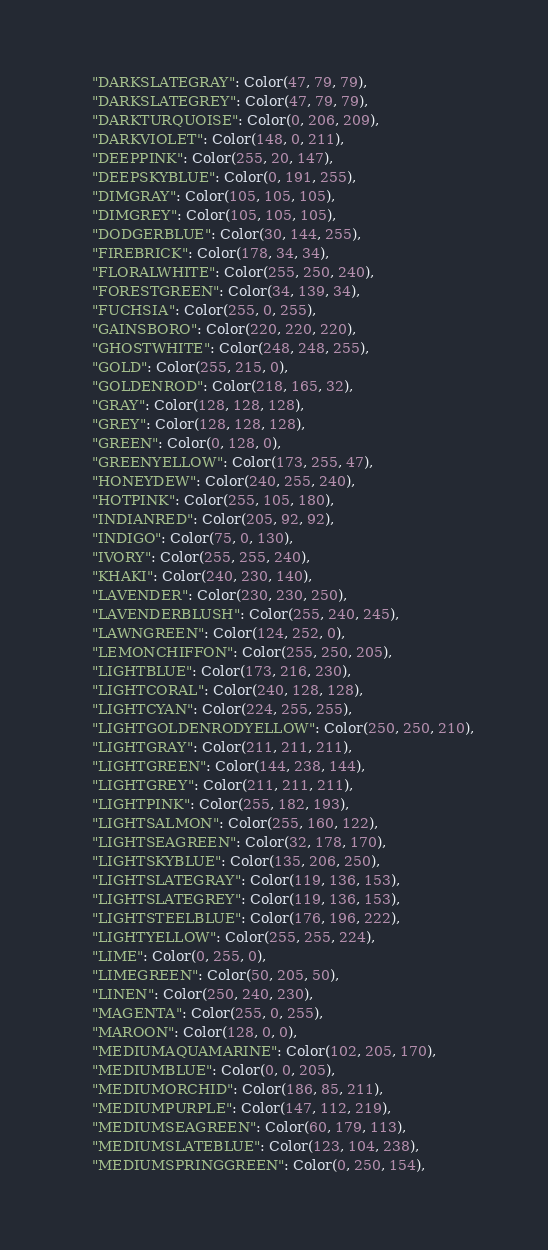<code> <loc_0><loc_0><loc_500><loc_500><_Python_>    "DARKSLATEGRAY": Color(47, 79, 79),
    "DARKSLATEGREY": Color(47, 79, 79),
    "DARKTURQUOISE": Color(0, 206, 209),
    "DARKVIOLET": Color(148, 0, 211),
    "DEEPPINK": Color(255, 20, 147),
    "DEEPSKYBLUE": Color(0, 191, 255),
    "DIMGRAY": Color(105, 105, 105),
    "DIMGREY": Color(105, 105, 105),
    "DODGERBLUE": Color(30, 144, 255),
    "FIREBRICK": Color(178, 34, 34),
    "FLORALWHITE": Color(255, 250, 240),
    "FORESTGREEN": Color(34, 139, 34),
    "FUCHSIA": Color(255, 0, 255),
    "GAINSBORO": Color(220, 220, 220),
    "GHOSTWHITE": Color(248, 248, 255),
    "GOLD": Color(255, 215, 0),
    "GOLDENROD": Color(218, 165, 32),
    "GRAY": Color(128, 128, 128),
    "GREY": Color(128, 128, 128),
    "GREEN": Color(0, 128, 0),
    "GREENYELLOW": Color(173, 255, 47),
    "HONEYDEW": Color(240, 255, 240),
    "HOTPINK": Color(255, 105, 180),
    "INDIANRED": Color(205, 92, 92),
    "INDIGO": Color(75, 0, 130),
    "IVORY": Color(255, 255, 240),
    "KHAKI": Color(240, 230, 140),
    "LAVENDER": Color(230, 230, 250),
    "LAVENDERBLUSH": Color(255, 240, 245),
    "LAWNGREEN": Color(124, 252, 0),
    "LEMONCHIFFON": Color(255, 250, 205),
    "LIGHTBLUE": Color(173, 216, 230),
    "LIGHTCORAL": Color(240, 128, 128),
    "LIGHTCYAN": Color(224, 255, 255),
    "LIGHTGOLDENRODYELLOW": Color(250, 250, 210),
    "LIGHTGRAY": Color(211, 211, 211),
    "LIGHTGREEN": Color(144, 238, 144),
    "LIGHTGREY": Color(211, 211, 211),
    "LIGHTPINK": Color(255, 182, 193),
    "LIGHTSALMON": Color(255, 160, 122),
    "LIGHTSEAGREEN": Color(32, 178, 170),
    "LIGHTSKYBLUE": Color(135, 206, 250),
    "LIGHTSLATEGRAY": Color(119, 136, 153),
    "LIGHTSLATEGREY": Color(119, 136, 153),
    "LIGHTSTEELBLUE": Color(176, 196, 222),
    "LIGHTYELLOW": Color(255, 255, 224),
    "LIME": Color(0, 255, 0),
    "LIMEGREEN": Color(50, 205, 50),
    "LINEN": Color(250, 240, 230),
    "MAGENTA": Color(255, 0, 255),
    "MAROON": Color(128, 0, 0),
    "MEDIUMAQUAMARINE": Color(102, 205, 170),
    "MEDIUMBLUE": Color(0, 0, 205),
    "MEDIUMORCHID": Color(186, 85, 211),
    "MEDIUMPURPLE": Color(147, 112, 219),
    "MEDIUMSEAGREEN": Color(60, 179, 113),
    "MEDIUMSLATEBLUE": Color(123, 104, 238),
    "MEDIUMSPRINGGREEN": Color(0, 250, 154),</code> 